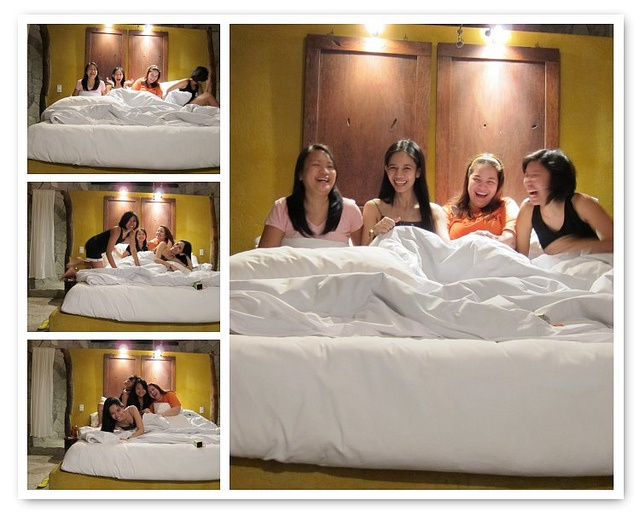Describe the objects in this image and their specific colors. I can see bed in white, darkgray, and lightgray tones, bed in white, darkgray, and lightgray tones, bed in white, darkgray, and lightgray tones, bed in white, darkgray, and lightgray tones, and people in white, black, brown, and tan tones in this image. 